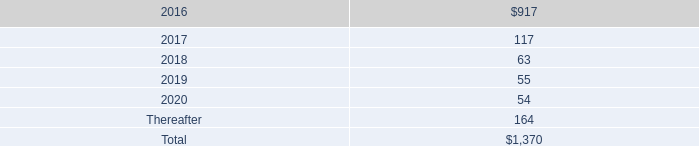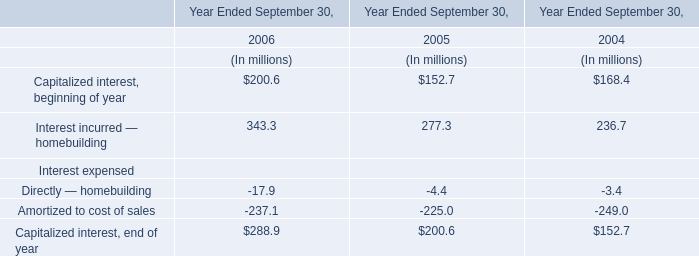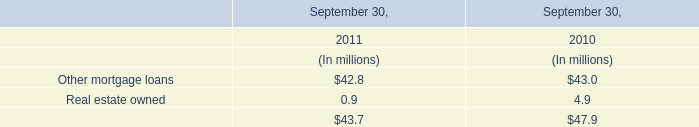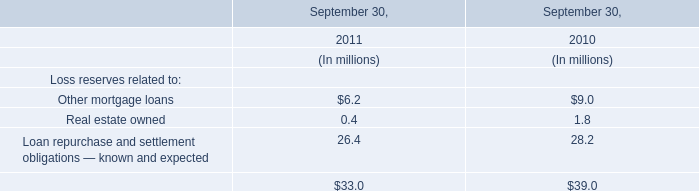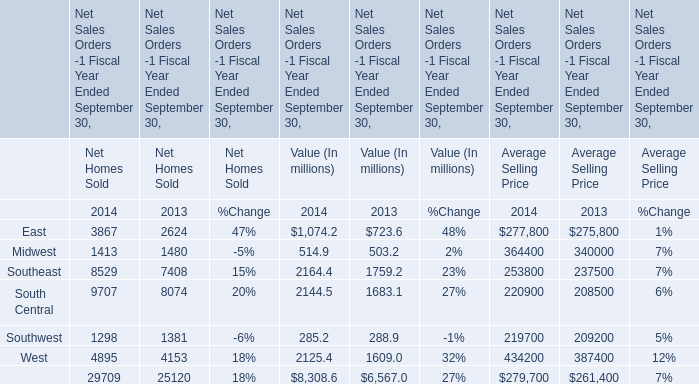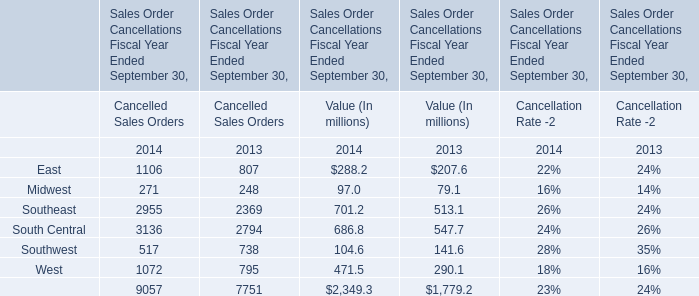Which element makes up more than 20 % of the total for Value (In millions) in 2013? 
Answer: Southeast, South Central. 